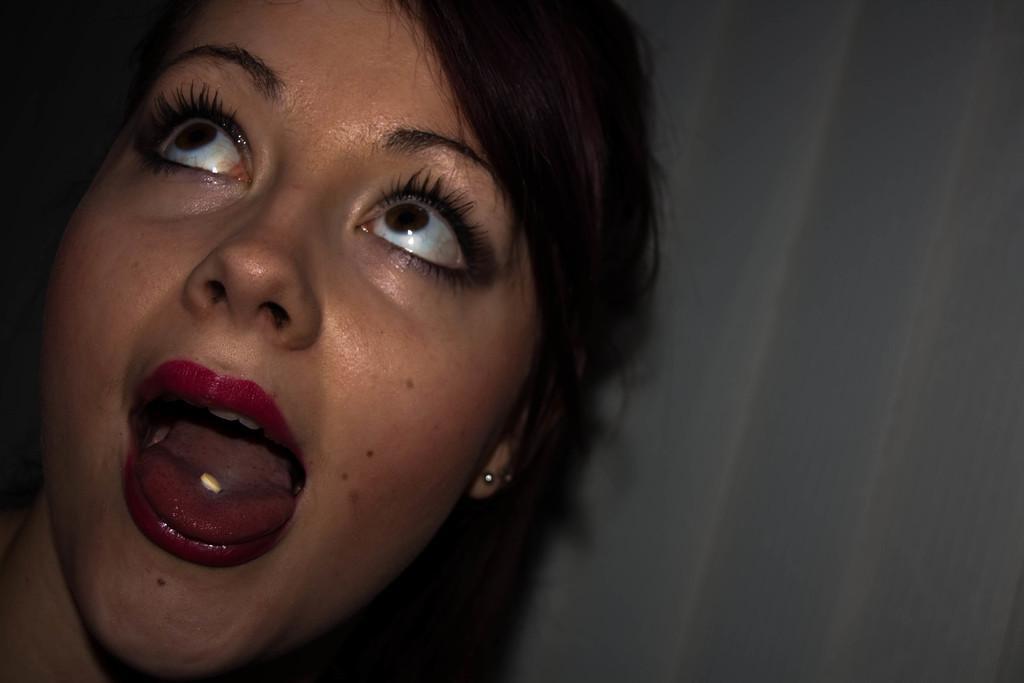How would you summarize this image in a sentence or two? In this image we can see a woman, in her mouth we can see a tablet and also we can see the wall. 